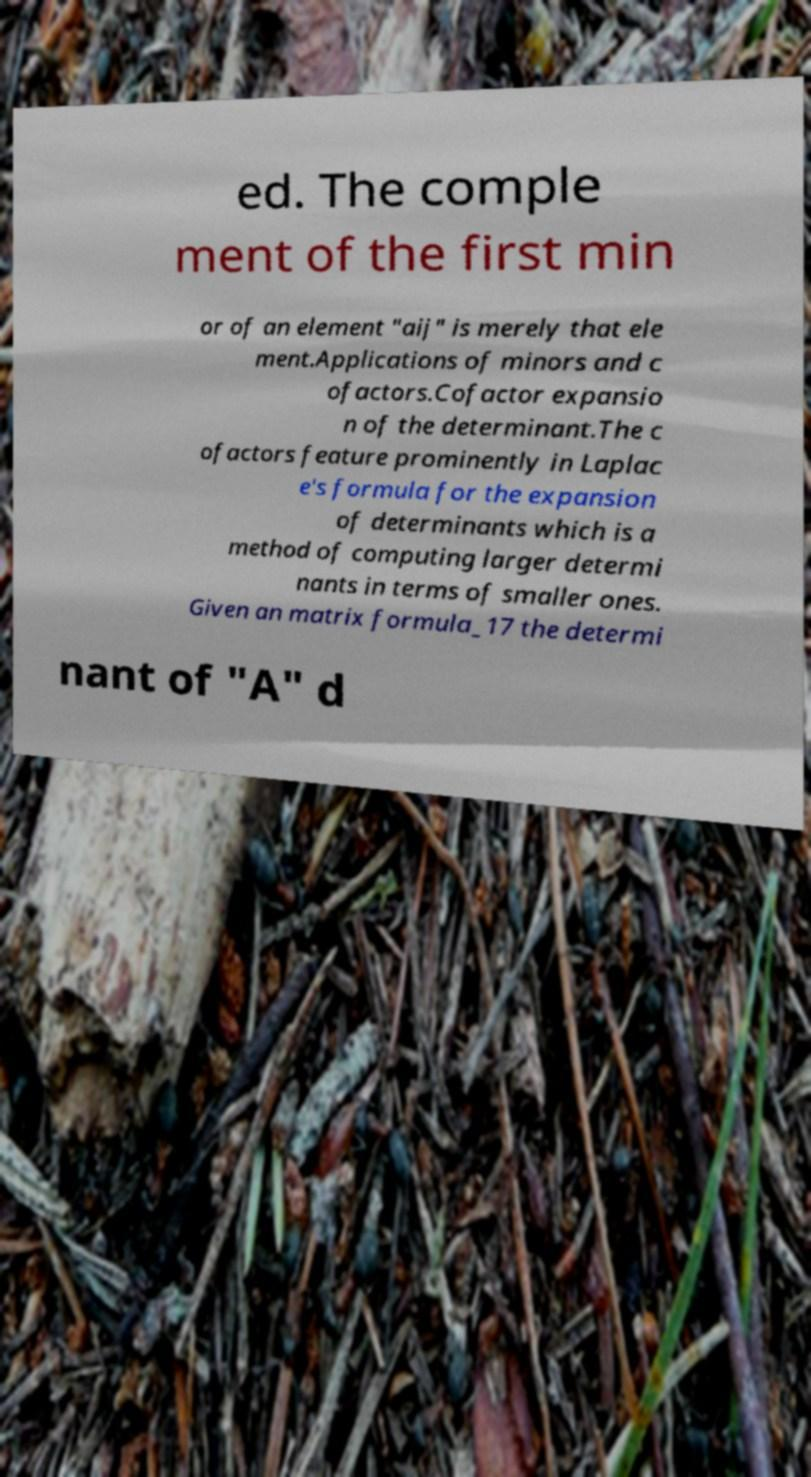What messages or text are displayed in this image? I need them in a readable, typed format. ed. The comple ment of the first min or of an element "aij" is merely that ele ment.Applications of minors and c ofactors.Cofactor expansio n of the determinant.The c ofactors feature prominently in Laplac e's formula for the expansion of determinants which is a method of computing larger determi nants in terms of smaller ones. Given an matrix formula_17 the determi nant of "A" d 